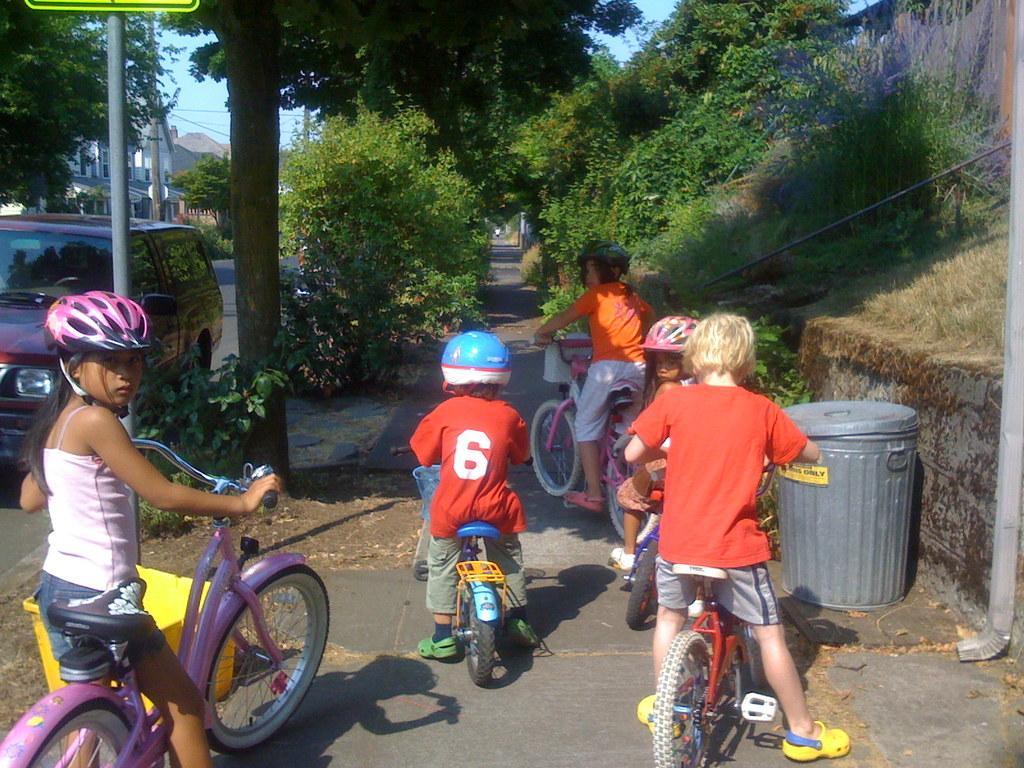How would you summarize this image in a sentence or two? In this image i can see a group of children riding bicycle on a road at a the back ground i can see a dustbin a car, a board, a tree, a building and sky. 